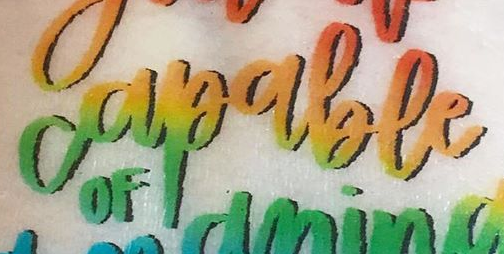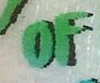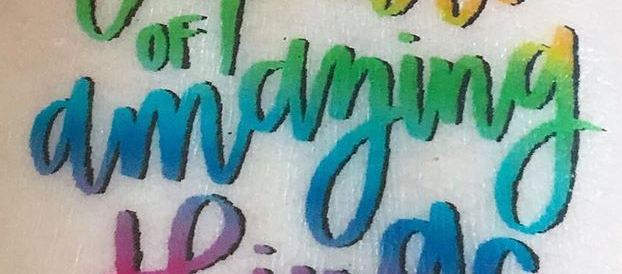Read the text from these images in sequence, separated by a semicolon. capable; OF; amaying 